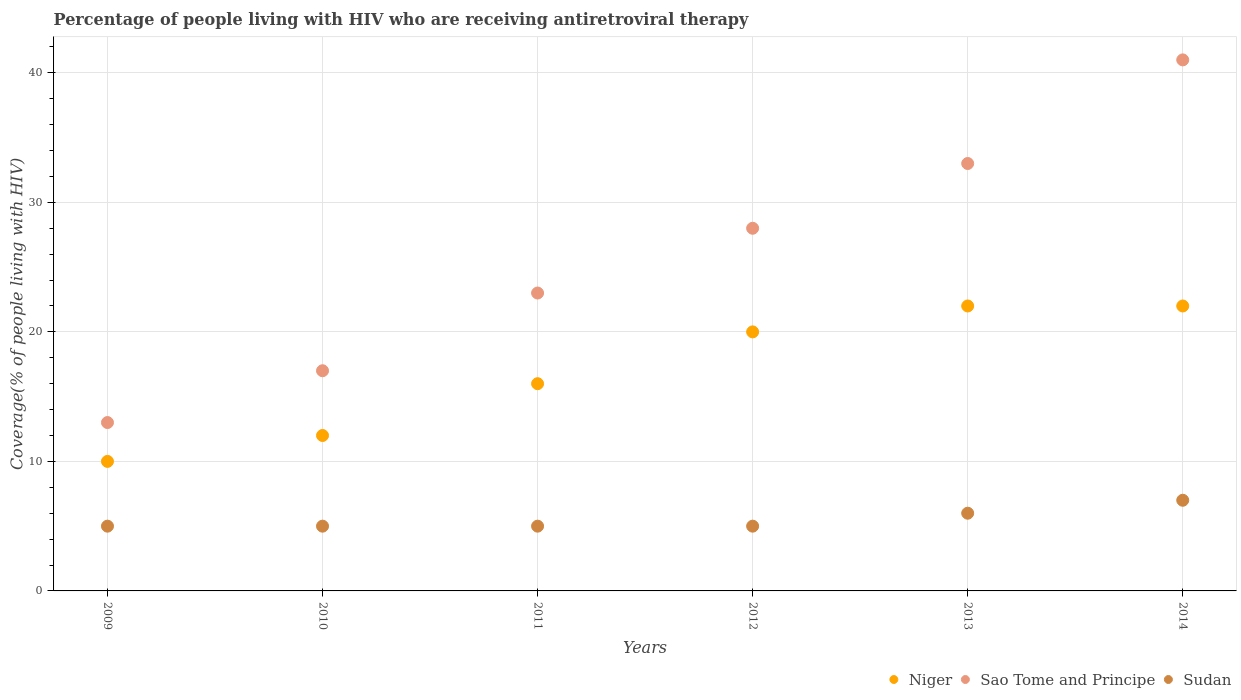How many different coloured dotlines are there?
Your answer should be very brief. 3. Is the number of dotlines equal to the number of legend labels?
Offer a terse response. Yes. What is the percentage of the HIV infected people who are receiving antiretroviral therapy in Sudan in 2009?
Your answer should be very brief. 5. Across all years, what is the maximum percentage of the HIV infected people who are receiving antiretroviral therapy in Niger?
Provide a short and direct response. 22. Across all years, what is the minimum percentage of the HIV infected people who are receiving antiretroviral therapy in Sudan?
Your answer should be compact. 5. In which year was the percentage of the HIV infected people who are receiving antiretroviral therapy in Sao Tome and Principe maximum?
Your answer should be very brief. 2014. What is the total percentage of the HIV infected people who are receiving antiretroviral therapy in Sao Tome and Principe in the graph?
Provide a short and direct response. 155. What is the difference between the percentage of the HIV infected people who are receiving antiretroviral therapy in Niger in 2010 and that in 2014?
Offer a terse response. -10. What is the difference between the percentage of the HIV infected people who are receiving antiretroviral therapy in Sudan in 2013 and the percentage of the HIV infected people who are receiving antiretroviral therapy in Niger in 2014?
Offer a very short reply. -16. What is the average percentage of the HIV infected people who are receiving antiretroviral therapy in Sudan per year?
Offer a terse response. 5.5. In the year 2013, what is the difference between the percentage of the HIV infected people who are receiving antiretroviral therapy in Sudan and percentage of the HIV infected people who are receiving antiretroviral therapy in Niger?
Provide a succinct answer. -16. What is the ratio of the percentage of the HIV infected people who are receiving antiretroviral therapy in Sao Tome and Principe in 2009 to that in 2012?
Your answer should be compact. 0.46. Is the percentage of the HIV infected people who are receiving antiretroviral therapy in Niger in 2011 less than that in 2014?
Provide a short and direct response. Yes. What is the difference between the highest and the second highest percentage of the HIV infected people who are receiving antiretroviral therapy in Niger?
Make the answer very short. 0. What is the difference between the highest and the lowest percentage of the HIV infected people who are receiving antiretroviral therapy in Sudan?
Provide a short and direct response. 2. Does the percentage of the HIV infected people who are receiving antiretroviral therapy in Sao Tome and Principe monotonically increase over the years?
Your answer should be compact. Yes. How many years are there in the graph?
Provide a succinct answer. 6. What is the difference between two consecutive major ticks on the Y-axis?
Make the answer very short. 10. Does the graph contain any zero values?
Offer a very short reply. No. Does the graph contain grids?
Provide a succinct answer. Yes. Where does the legend appear in the graph?
Make the answer very short. Bottom right. How many legend labels are there?
Give a very brief answer. 3. What is the title of the graph?
Your answer should be very brief. Percentage of people living with HIV who are receiving antiretroviral therapy. Does "Cabo Verde" appear as one of the legend labels in the graph?
Your answer should be very brief. No. What is the label or title of the X-axis?
Ensure brevity in your answer.  Years. What is the label or title of the Y-axis?
Ensure brevity in your answer.  Coverage(% of people living with HIV). What is the Coverage(% of people living with HIV) of Sao Tome and Principe in 2010?
Keep it short and to the point. 17. What is the Coverage(% of people living with HIV) of Sudan in 2010?
Offer a very short reply. 5. What is the Coverage(% of people living with HIV) of Niger in 2011?
Your response must be concise. 16. What is the Coverage(% of people living with HIV) in Sudan in 2011?
Provide a short and direct response. 5. What is the Coverage(% of people living with HIV) in Niger in 2012?
Your answer should be very brief. 20. What is the Coverage(% of people living with HIV) in Sudan in 2012?
Your answer should be very brief. 5. What is the Coverage(% of people living with HIV) in Niger in 2013?
Ensure brevity in your answer.  22. What is the Coverage(% of people living with HIV) in Sao Tome and Principe in 2013?
Keep it short and to the point. 33. What is the Coverage(% of people living with HIV) in Sudan in 2013?
Your answer should be compact. 6. What is the Coverage(% of people living with HIV) of Sao Tome and Principe in 2014?
Offer a very short reply. 41. Across all years, what is the maximum Coverage(% of people living with HIV) in Niger?
Provide a succinct answer. 22. Across all years, what is the maximum Coverage(% of people living with HIV) of Sao Tome and Principe?
Provide a succinct answer. 41. Across all years, what is the minimum Coverage(% of people living with HIV) in Niger?
Provide a short and direct response. 10. What is the total Coverage(% of people living with HIV) of Niger in the graph?
Provide a short and direct response. 102. What is the total Coverage(% of people living with HIV) in Sao Tome and Principe in the graph?
Provide a succinct answer. 155. What is the difference between the Coverage(% of people living with HIV) in Niger in 2009 and that in 2010?
Keep it short and to the point. -2. What is the difference between the Coverage(% of people living with HIV) in Sudan in 2009 and that in 2011?
Make the answer very short. 0. What is the difference between the Coverage(% of people living with HIV) of Niger in 2009 and that in 2012?
Your answer should be compact. -10. What is the difference between the Coverage(% of people living with HIV) in Sudan in 2009 and that in 2013?
Your answer should be very brief. -1. What is the difference between the Coverage(% of people living with HIV) of Sao Tome and Principe in 2009 and that in 2014?
Offer a terse response. -28. What is the difference between the Coverage(% of people living with HIV) of Sudan in 2009 and that in 2014?
Your response must be concise. -2. What is the difference between the Coverage(% of people living with HIV) in Sudan in 2010 and that in 2011?
Offer a very short reply. 0. What is the difference between the Coverage(% of people living with HIV) in Sudan in 2010 and that in 2013?
Your response must be concise. -1. What is the difference between the Coverage(% of people living with HIV) of Niger in 2010 and that in 2014?
Give a very brief answer. -10. What is the difference between the Coverage(% of people living with HIV) in Sudan in 2010 and that in 2014?
Your answer should be compact. -2. What is the difference between the Coverage(% of people living with HIV) in Niger in 2011 and that in 2012?
Provide a short and direct response. -4. What is the difference between the Coverage(% of people living with HIV) of Sao Tome and Principe in 2011 and that in 2012?
Give a very brief answer. -5. What is the difference between the Coverage(% of people living with HIV) in Sudan in 2011 and that in 2012?
Keep it short and to the point. 0. What is the difference between the Coverage(% of people living with HIV) of Sao Tome and Principe in 2011 and that in 2013?
Make the answer very short. -10. What is the difference between the Coverage(% of people living with HIV) of Niger in 2011 and that in 2014?
Provide a succinct answer. -6. What is the difference between the Coverage(% of people living with HIV) of Sao Tome and Principe in 2011 and that in 2014?
Ensure brevity in your answer.  -18. What is the difference between the Coverage(% of people living with HIV) in Niger in 2012 and that in 2013?
Give a very brief answer. -2. What is the difference between the Coverage(% of people living with HIV) of Sao Tome and Principe in 2012 and that in 2013?
Offer a terse response. -5. What is the difference between the Coverage(% of people living with HIV) of Sao Tome and Principe in 2012 and that in 2014?
Provide a short and direct response. -13. What is the difference between the Coverage(% of people living with HIV) in Sudan in 2012 and that in 2014?
Provide a succinct answer. -2. What is the difference between the Coverage(% of people living with HIV) of Sao Tome and Principe in 2013 and that in 2014?
Give a very brief answer. -8. What is the difference between the Coverage(% of people living with HIV) of Sudan in 2013 and that in 2014?
Keep it short and to the point. -1. What is the difference between the Coverage(% of people living with HIV) in Niger in 2009 and the Coverage(% of people living with HIV) in Sao Tome and Principe in 2010?
Ensure brevity in your answer.  -7. What is the difference between the Coverage(% of people living with HIV) of Niger in 2009 and the Coverage(% of people living with HIV) of Sudan in 2010?
Your answer should be compact. 5. What is the difference between the Coverage(% of people living with HIV) of Sao Tome and Principe in 2009 and the Coverage(% of people living with HIV) of Sudan in 2010?
Ensure brevity in your answer.  8. What is the difference between the Coverage(% of people living with HIV) in Niger in 2009 and the Coverage(% of people living with HIV) in Sao Tome and Principe in 2011?
Provide a succinct answer. -13. What is the difference between the Coverage(% of people living with HIV) of Niger in 2009 and the Coverage(% of people living with HIV) of Sao Tome and Principe in 2012?
Provide a succinct answer. -18. What is the difference between the Coverage(% of people living with HIV) of Niger in 2009 and the Coverage(% of people living with HIV) of Sudan in 2013?
Your answer should be compact. 4. What is the difference between the Coverage(% of people living with HIV) of Niger in 2009 and the Coverage(% of people living with HIV) of Sao Tome and Principe in 2014?
Offer a terse response. -31. What is the difference between the Coverage(% of people living with HIV) in Niger in 2009 and the Coverage(% of people living with HIV) in Sudan in 2014?
Your answer should be very brief. 3. What is the difference between the Coverage(% of people living with HIV) in Niger in 2010 and the Coverage(% of people living with HIV) in Sao Tome and Principe in 2012?
Make the answer very short. -16. What is the difference between the Coverage(% of people living with HIV) of Sao Tome and Principe in 2010 and the Coverage(% of people living with HIV) of Sudan in 2012?
Keep it short and to the point. 12. What is the difference between the Coverage(% of people living with HIV) of Niger in 2010 and the Coverage(% of people living with HIV) of Sao Tome and Principe in 2013?
Keep it short and to the point. -21. What is the difference between the Coverage(% of people living with HIV) in Niger in 2010 and the Coverage(% of people living with HIV) in Sudan in 2013?
Your response must be concise. 6. What is the difference between the Coverage(% of people living with HIV) of Sao Tome and Principe in 2010 and the Coverage(% of people living with HIV) of Sudan in 2013?
Offer a very short reply. 11. What is the difference between the Coverage(% of people living with HIV) in Niger in 2011 and the Coverage(% of people living with HIV) in Sudan in 2012?
Make the answer very short. 11. What is the difference between the Coverage(% of people living with HIV) of Sao Tome and Principe in 2011 and the Coverage(% of people living with HIV) of Sudan in 2012?
Your answer should be compact. 18. What is the difference between the Coverage(% of people living with HIV) of Niger in 2011 and the Coverage(% of people living with HIV) of Sudan in 2013?
Your answer should be very brief. 10. What is the difference between the Coverage(% of people living with HIV) in Sao Tome and Principe in 2011 and the Coverage(% of people living with HIV) in Sudan in 2014?
Your answer should be compact. 16. What is the difference between the Coverage(% of people living with HIV) in Niger in 2012 and the Coverage(% of people living with HIV) in Sao Tome and Principe in 2013?
Give a very brief answer. -13. What is the difference between the Coverage(% of people living with HIV) in Niger in 2012 and the Coverage(% of people living with HIV) in Sao Tome and Principe in 2014?
Give a very brief answer. -21. What is the difference between the Coverage(% of people living with HIV) of Niger in 2012 and the Coverage(% of people living with HIV) of Sudan in 2014?
Provide a succinct answer. 13. What is the difference between the Coverage(% of people living with HIV) of Sao Tome and Principe in 2012 and the Coverage(% of people living with HIV) of Sudan in 2014?
Provide a short and direct response. 21. What is the difference between the Coverage(% of people living with HIV) of Niger in 2013 and the Coverage(% of people living with HIV) of Sao Tome and Principe in 2014?
Your answer should be very brief. -19. What is the difference between the Coverage(% of people living with HIV) in Sao Tome and Principe in 2013 and the Coverage(% of people living with HIV) in Sudan in 2014?
Ensure brevity in your answer.  26. What is the average Coverage(% of people living with HIV) of Sao Tome and Principe per year?
Your answer should be compact. 25.83. In the year 2009, what is the difference between the Coverage(% of people living with HIV) of Niger and Coverage(% of people living with HIV) of Sudan?
Give a very brief answer. 5. In the year 2010, what is the difference between the Coverage(% of people living with HIV) in Niger and Coverage(% of people living with HIV) in Sudan?
Ensure brevity in your answer.  7. In the year 2010, what is the difference between the Coverage(% of people living with HIV) in Sao Tome and Principe and Coverage(% of people living with HIV) in Sudan?
Provide a short and direct response. 12. In the year 2013, what is the difference between the Coverage(% of people living with HIV) in Niger and Coverage(% of people living with HIV) in Sao Tome and Principe?
Offer a terse response. -11. In the year 2013, what is the difference between the Coverage(% of people living with HIV) in Niger and Coverage(% of people living with HIV) in Sudan?
Offer a very short reply. 16. In the year 2013, what is the difference between the Coverage(% of people living with HIV) of Sao Tome and Principe and Coverage(% of people living with HIV) of Sudan?
Your response must be concise. 27. In the year 2014, what is the difference between the Coverage(% of people living with HIV) in Sao Tome and Principe and Coverage(% of people living with HIV) in Sudan?
Give a very brief answer. 34. What is the ratio of the Coverage(% of people living with HIV) of Sao Tome and Principe in 2009 to that in 2010?
Ensure brevity in your answer.  0.76. What is the ratio of the Coverage(% of people living with HIV) of Sudan in 2009 to that in 2010?
Make the answer very short. 1. What is the ratio of the Coverage(% of people living with HIV) in Niger in 2009 to that in 2011?
Offer a very short reply. 0.62. What is the ratio of the Coverage(% of people living with HIV) in Sao Tome and Principe in 2009 to that in 2011?
Make the answer very short. 0.57. What is the ratio of the Coverage(% of people living with HIV) in Niger in 2009 to that in 2012?
Keep it short and to the point. 0.5. What is the ratio of the Coverage(% of people living with HIV) in Sao Tome and Principe in 2009 to that in 2012?
Ensure brevity in your answer.  0.46. What is the ratio of the Coverage(% of people living with HIV) in Sudan in 2009 to that in 2012?
Offer a terse response. 1. What is the ratio of the Coverage(% of people living with HIV) of Niger in 2009 to that in 2013?
Your response must be concise. 0.45. What is the ratio of the Coverage(% of people living with HIV) in Sao Tome and Principe in 2009 to that in 2013?
Give a very brief answer. 0.39. What is the ratio of the Coverage(% of people living with HIV) in Niger in 2009 to that in 2014?
Your answer should be compact. 0.45. What is the ratio of the Coverage(% of people living with HIV) of Sao Tome and Principe in 2009 to that in 2014?
Provide a short and direct response. 0.32. What is the ratio of the Coverage(% of people living with HIV) of Niger in 2010 to that in 2011?
Give a very brief answer. 0.75. What is the ratio of the Coverage(% of people living with HIV) of Sao Tome and Principe in 2010 to that in 2011?
Your response must be concise. 0.74. What is the ratio of the Coverage(% of people living with HIV) of Sudan in 2010 to that in 2011?
Give a very brief answer. 1. What is the ratio of the Coverage(% of people living with HIV) of Sao Tome and Principe in 2010 to that in 2012?
Offer a very short reply. 0.61. What is the ratio of the Coverage(% of people living with HIV) of Niger in 2010 to that in 2013?
Provide a short and direct response. 0.55. What is the ratio of the Coverage(% of people living with HIV) of Sao Tome and Principe in 2010 to that in 2013?
Your answer should be very brief. 0.52. What is the ratio of the Coverage(% of people living with HIV) in Niger in 2010 to that in 2014?
Provide a short and direct response. 0.55. What is the ratio of the Coverage(% of people living with HIV) of Sao Tome and Principe in 2010 to that in 2014?
Ensure brevity in your answer.  0.41. What is the ratio of the Coverage(% of people living with HIV) of Sudan in 2010 to that in 2014?
Your response must be concise. 0.71. What is the ratio of the Coverage(% of people living with HIV) of Niger in 2011 to that in 2012?
Your answer should be compact. 0.8. What is the ratio of the Coverage(% of people living with HIV) in Sao Tome and Principe in 2011 to that in 2012?
Keep it short and to the point. 0.82. What is the ratio of the Coverage(% of people living with HIV) of Niger in 2011 to that in 2013?
Your response must be concise. 0.73. What is the ratio of the Coverage(% of people living with HIV) in Sao Tome and Principe in 2011 to that in 2013?
Offer a terse response. 0.7. What is the ratio of the Coverage(% of people living with HIV) of Niger in 2011 to that in 2014?
Keep it short and to the point. 0.73. What is the ratio of the Coverage(% of people living with HIV) of Sao Tome and Principe in 2011 to that in 2014?
Your answer should be very brief. 0.56. What is the ratio of the Coverage(% of people living with HIV) in Sudan in 2011 to that in 2014?
Provide a short and direct response. 0.71. What is the ratio of the Coverage(% of people living with HIV) of Sao Tome and Principe in 2012 to that in 2013?
Offer a very short reply. 0.85. What is the ratio of the Coverage(% of people living with HIV) in Sao Tome and Principe in 2012 to that in 2014?
Make the answer very short. 0.68. What is the ratio of the Coverage(% of people living with HIV) in Sao Tome and Principe in 2013 to that in 2014?
Your answer should be very brief. 0.8. What is the ratio of the Coverage(% of people living with HIV) in Sudan in 2013 to that in 2014?
Your answer should be compact. 0.86. What is the difference between the highest and the lowest Coverage(% of people living with HIV) in Niger?
Keep it short and to the point. 12. What is the difference between the highest and the lowest Coverage(% of people living with HIV) of Sudan?
Provide a short and direct response. 2. 